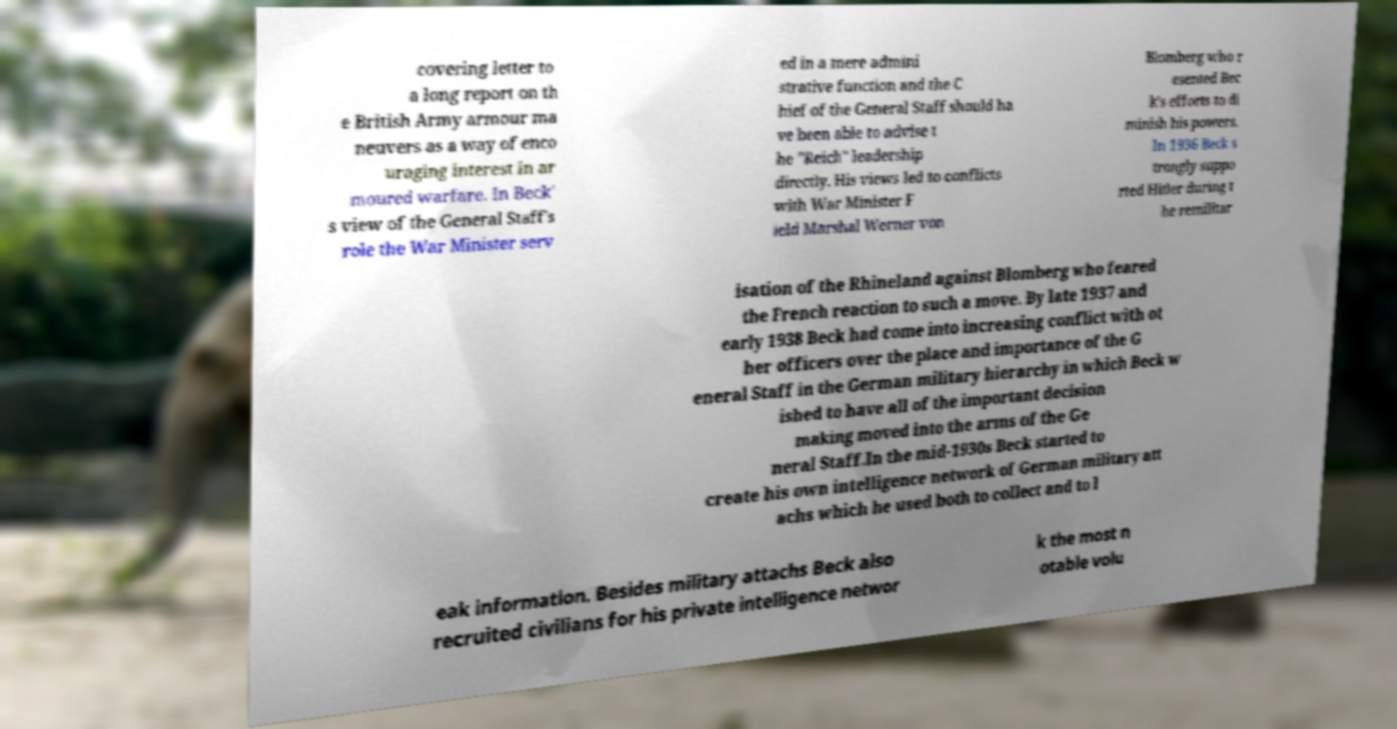There's text embedded in this image that I need extracted. Can you transcribe it verbatim? covering letter to a long report on th e British Army armour ma neuvers as a way of enco uraging interest in ar moured warfare. In Beck' s view of the General Staff's role the War Minister serv ed in a mere admini strative function and the C hief of the General Staff should ha ve been able to advise t he "Reich" leadership directly. His views led to conflicts with War Minister F ield Marshal Werner von Blomberg who r esented Bec k's efforts to di minish his powers. In 1936 Beck s trongly suppo rted Hitler during t he remilitar isation of the Rhineland against Blomberg who feared the French reaction to such a move. By late 1937 and early 1938 Beck had come into increasing conflict with ot her officers over the place and importance of the G eneral Staff in the German military hierarchy in which Beck w ished to have all of the important decision making moved into the arms of the Ge neral Staff.In the mid-1930s Beck started to create his own intelligence network of German military att achs which he used both to collect and to l eak information. Besides military attachs Beck also recruited civilians for his private intelligence networ k the most n otable volu 